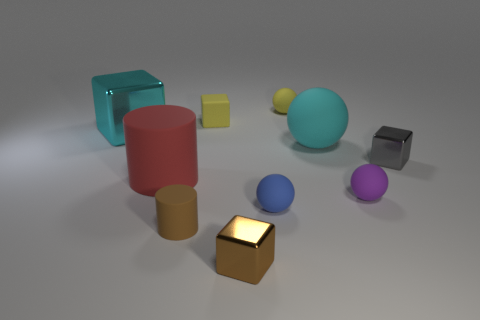Subtract 1 cubes. How many cubes are left? 3 Subtract all spheres. How many objects are left? 6 Add 5 large cyan metallic objects. How many large cyan metallic objects are left? 6 Add 2 gray metallic cubes. How many gray metallic cubes exist? 3 Subtract 0 gray cylinders. How many objects are left? 10 Subtract all tiny gray blocks. Subtract all purple rubber objects. How many objects are left? 8 